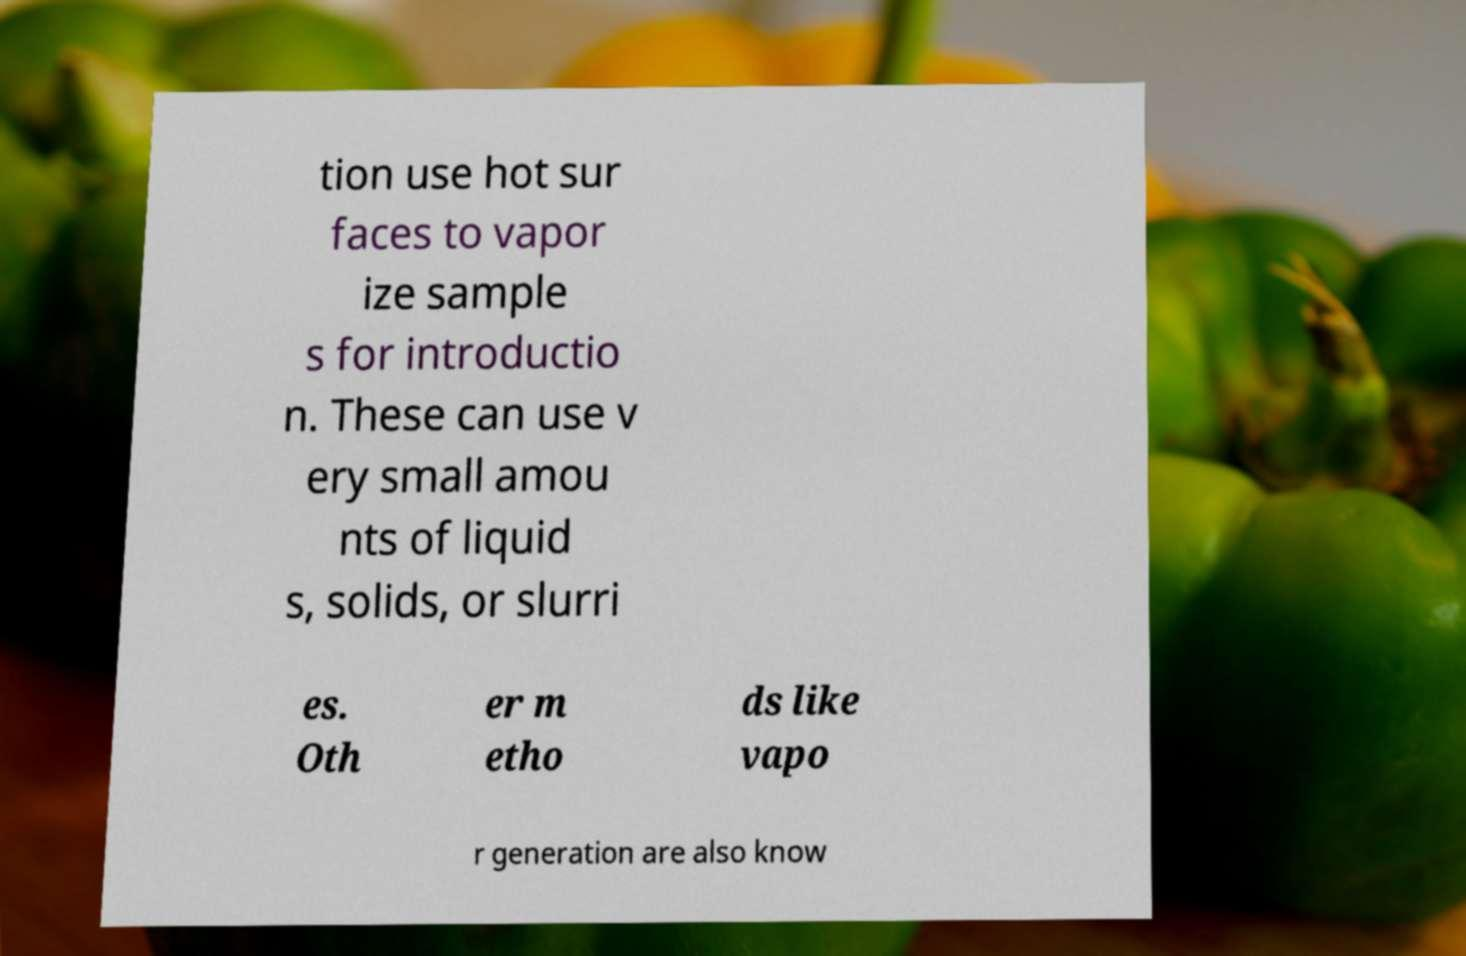For documentation purposes, I need the text within this image transcribed. Could you provide that? tion use hot sur faces to vapor ize sample s for introductio n. These can use v ery small amou nts of liquid s, solids, or slurri es. Oth er m etho ds like vapo r generation are also know 